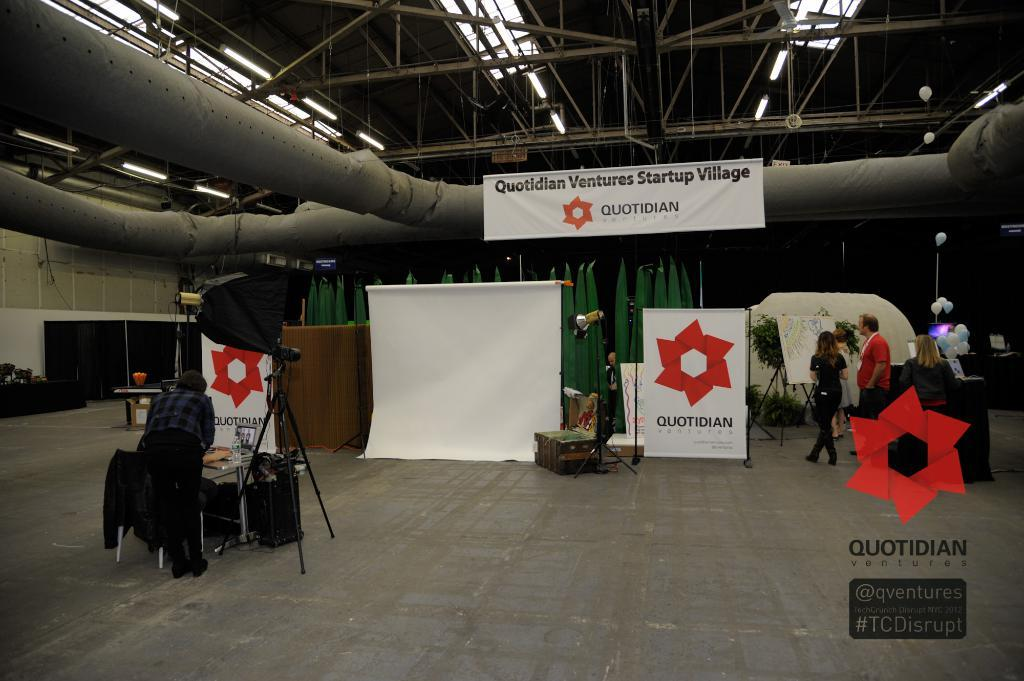<image>
Write a terse but informative summary of the picture. The Quotidian Ventures Startup Village has a number of exhibitors. 